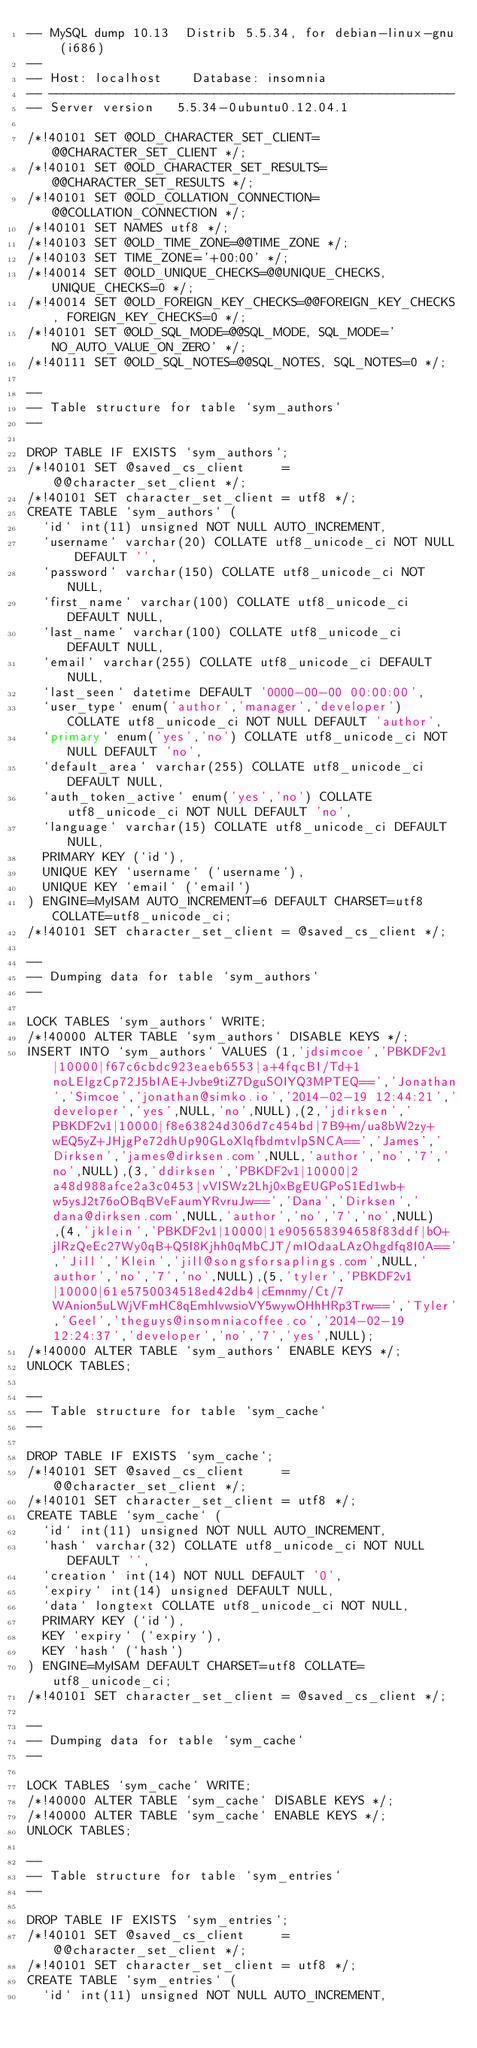<code> <loc_0><loc_0><loc_500><loc_500><_SQL_>-- MySQL dump 10.13  Distrib 5.5.34, for debian-linux-gnu (i686)
--
-- Host: localhost    Database: insomnia
-- ------------------------------------------------------
-- Server version	5.5.34-0ubuntu0.12.04.1

/*!40101 SET @OLD_CHARACTER_SET_CLIENT=@@CHARACTER_SET_CLIENT */;
/*!40101 SET @OLD_CHARACTER_SET_RESULTS=@@CHARACTER_SET_RESULTS */;
/*!40101 SET @OLD_COLLATION_CONNECTION=@@COLLATION_CONNECTION */;
/*!40101 SET NAMES utf8 */;
/*!40103 SET @OLD_TIME_ZONE=@@TIME_ZONE */;
/*!40103 SET TIME_ZONE='+00:00' */;
/*!40014 SET @OLD_UNIQUE_CHECKS=@@UNIQUE_CHECKS, UNIQUE_CHECKS=0 */;
/*!40014 SET @OLD_FOREIGN_KEY_CHECKS=@@FOREIGN_KEY_CHECKS, FOREIGN_KEY_CHECKS=0 */;
/*!40101 SET @OLD_SQL_MODE=@@SQL_MODE, SQL_MODE='NO_AUTO_VALUE_ON_ZERO' */;
/*!40111 SET @OLD_SQL_NOTES=@@SQL_NOTES, SQL_NOTES=0 */;

--
-- Table structure for table `sym_authors`
--

DROP TABLE IF EXISTS `sym_authors`;
/*!40101 SET @saved_cs_client     = @@character_set_client */;
/*!40101 SET character_set_client = utf8 */;
CREATE TABLE `sym_authors` (
  `id` int(11) unsigned NOT NULL AUTO_INCREMENT,
  `username` varchar(20) COLLATE utf8_unicode_ci NOT NULL DEFAULT '',
  `password` varchar(150) COLLATE utf8_unicode_ci NOT NULL,
  `first_name` varchar(100) COLLATE utf8_unicode_ci DEFAULT NULL,
  `last_name` varchar(100) COLLATE utf8_unicode_ci DEFAULT NULL,
  `email` varchar(255) COLLATE utf8_unicode_ci DEFAULT NULL,
  `last_seen` datetime DEFAULT '0000-00-00 00:00:00',
  `user_type` enum('author','manager','developer') COLLATE utf8_unicode_ci NOT NULL DEFAULT 'author',
  `primary` enum('yes','no') COLLATE utf8_unicode_ci NOT NULL DEFAULT 'no',
  `default_area` varchar(255) COLLATE utf8_unicode_ci DEFAULT NULL,
  `auth_token_active` enum('yes','no') COLLATE utf8_unicode_ci NOT NULL DEFAULT 'no',
  `language` varchar(15) COLLATE utf8_unicode_ci DEFAULT NULL,
  PRIMARY KEY (`id`),
  UNIQUE KEY `username` (`username`),
  UNIQUE KEY `email` (`email`)
) ENGINE=MyISAM AUTO_INCREMENT=6 DEFAULT CHARSET=utf8 COLLATE=utf8_unicode_ci;
/*!40101 SET character_set_client = @saved_cs_client */;

--
-- Dumping data for table `sym_authors`
--

LOCK TABLES `sym_authors` WRITE;
/*!40000 ALTER TABLE `sym_authors` DISABLE KEYS */;
INSERT INTO `sym_authors` VALUES (1,'jdsimcoe','PBKDF2v1|10000|f67c6cbdc923eaeb6553|a+4fqcBI/Td+1noLElgzCp72J5bIAE+Jvbe9tiZ7DguSOIYQ3MPTEQ==','Jonathan','Simcoe','jonathan@simko.io','2014-02-19 12:44:21','developer','yes',NULL,'no',NULL),(2,'jdirksen','PBKDF2v1|10000|f8e63824d306d7c454bd|7B9+m/ua8bW2zy+wEQ5yZ+JHjgPe72dhUp90GLoXlqfbdmtvlpSNCA==','James','Dirksen','james@dirksen.com',NULL,'author','no','7','no',NULL),(3,'ddirksen','PBKDF2v1|10000|2a48d988afce2a3c0453|vVISWz2Lhj0xBgEUGPoS1Ed1wb+w5ysJ2t76oOBqBVeFaumYRvruJw==','Dana','Dirksen','dana@dirksen.com',NULL,'author','no','7','no',NULL),(4,'jklein','PBKDF2v1|10000|1e905658394658f83ddf|bO+jlRzQeEc27Wy0qB+Q5I8Kjhh0qMbCJT/mIOdaaLAzOhgdfq8I0A==','Jill','Klein','jill@songsforsaplings.com',NULL,'author','no','7','no',NULL),(5,'tyler','PBKDF2v1|10000|61e5750034518ed42db4|cEmnmy/Ct/7WAnion5uLWjVFmHC8qEmhIvwsioVY5wywOHhHRp3Trw==','Tyler','Geel','theguys@insomniacoffee.co','2014-02-19 12:24:37','developer','no','7','yes',NULL);
/*!40000 ALTER TABLE `sym_authors` ENABLE KEYS */;
UNLOCK TABLES;

--
-- Table structure for table `sym_cache`
--

DROP TABLE IF EXISTS `sym_cache`;
/*!40101 SET @saved_cs_client     = @@character_set_client */;
/*!40101 SET character_set_client = utf8 */;
CREATE TABLE `sym_cache` (
  `id` int(11) unsigned NOT NULL AUTO_INCREMENT,
  `hash` varchar(32) COLLATE utf8_unicode_ci NOT NULL DEFAULT '',
  `creation` int(14) NOT NULL DEFAULT '0',
  `expiry` int(14) unsigned DEFAULT NULL,
  `data` longtext COLLATE utf8_unicode_ci NOT NULL,
  PRIMARY KEY (`id`),
  KEY `expiry` (`expiry`),
  KEY `hash` (`hash`)
) ENGINE=MyISAM DEFAULT CHARSET=utf8 COLLATE=utf8_unicode_ci;
/*!40101 SET character_set_client = @saved_cs_client */;

--
-- Dumping data for table `sym_cache`
--

LOCK TABLES `sym_cache` WRITE;
/*!40000 ALTER TABLE `sym_cache` DISABLE KEYS */;
/*!40000 ALTER TABLE `sym_cache` ENABLE KEYS */;
UNLOCK TABLES;

--
-- Table structure for table `sym_entries`
--

DROP TABLE IF EXISTS `sym_entries`;
/*!40101 SET @saved_cs_client     = @@character_set_client */;
/*!40101 SET character_set_client = utf8 */;
CREATE TABLE `sym_entries` (
  `id` int(11) unsigned NOT NULL AUTO_INCREMENT,</code> 